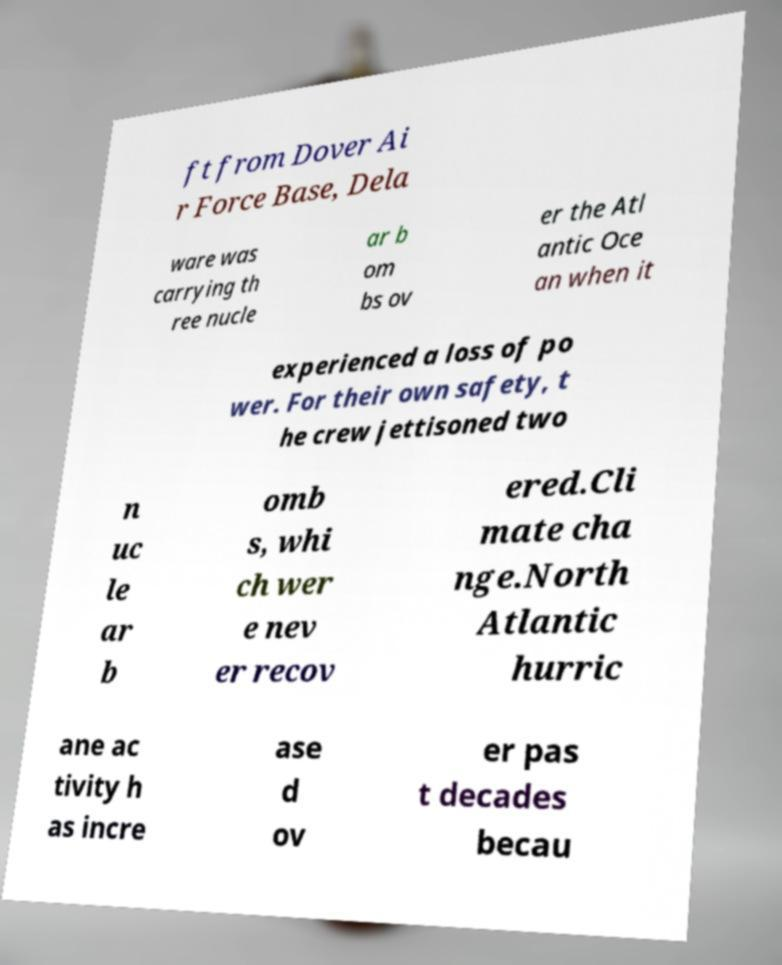Could you extract and type out the text from this image? ft from Dover Ai r Force Base, Dela ware was carrying th ree nucle ar b om bs ov er the Atl antic Oce an when it experienced a loss of po wer. For their own safety, t he crew jettisoned two n uc le ar b omb s, whi ch wer e nev er recov ered.Cli mate cha nge.North Atlantic hurric ane ac tivity h as incre ase d ov er pas t decades becau 